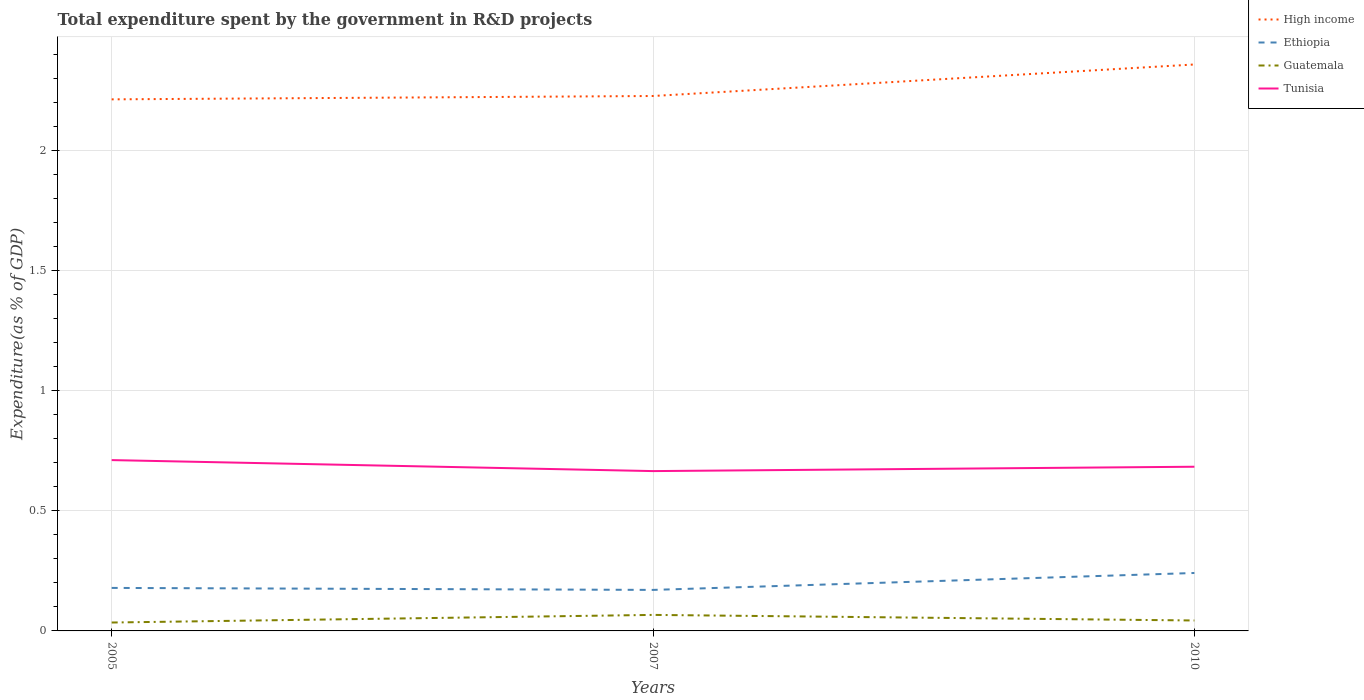How many different coloured lines are there?
Ensure brevity in your answer.  4. Across all years, what is the maximum total expenditure spent by the government in R&D projects in Guatemala?
Keep it short and to the point. 0.04. What is the total total expenditure spent by the government in R&D projects in High income in the graph?
Your response must be concise. -0.01. What is the difference between the highest and the second highest total expenditure spent by the government in R&D projects in Ethiopia?
Make the answer very short. 0.07. What is the difference between two consecutive major ticks on the Y-axis?
Provide a short and direct response. 0.5. Are the values on the major ticks of Y-axis written in scientific E-notation?
Offer a terse response. No. Does the graph contain any zero values?
Offer a very short reply. No. Where does the legend appear in the graph?
Your answer should be very brief. Top right. How are the legend labels stacked?
Keep it short and to the point. Vertical. What is the title of the graph?
Provide a succinct answer. Total expenditure spent by the government in R&D projects. What is the label or title of the Y-axis?
Your answer should be very brief. Expenditure(as % of GDP). What is the Expenditure(as % of GDP) in High income in 2005?
Make the answer very short. 2.21. What is the Expenditure(as % of GDP) of Ethiopia in 2005?
Provide a succinct answer. 0.18. What is the Expenditure(as % of GDP) in Guatemala in 2005?
Give a very brief answer. 0.04. What is the Expenditure(as % of GDP) in Tunisia in 2005?
Your answer should be compact. 0.71. What is the Expenditure(as % of GDP) of High income in 2007?
Make the answer very short. 2.23. What is the Expenditure(as % of GDP) of Ethiopia in 2007?
Give a very brief answer. 0.17. What is the Expenditure(as % of GDP) in Guatemala in 2007?
Offer a very short reply. 0.07. What is the Expenditure(as % of GDP) of Tunisia in 2007?
Provide a succinct answer. 0.67. What is the Expenditure(as % of GDP) in High income in 2010?
Keep it short and to the point. 2.36. What is the Expenditure(as % of GDP) of Ethiopia in 2010?
Offer a very short reply. 0.24. What is the Expenditure(as % of GDP) in Guatemala in 2010?
Provide a short and direct response. 0.04. What is the Expenditure(as % of GDP) of Tunisia in 2010?
Provide a succinct answer. 0.68. Across all years, what is the maximum Expenditure(as % of GDP) in High income?
Make the answer very short. 2.36. Across all years, what is the maximum Expenditure(as % of GDP) in Ethiopia?
Your answer should be compact. 0.24. Across all years, what is the maximum Expenditure(as % of GDP) in Guatemala?
Offer a very short reply. 0.07. Across all years, what is the maximum Expenditure(as % of GDP) in Tunisia?
Offer a terse response. 0.71. Across all years, what is the minimum Expenditure(as % of GDP) in High income?
Give a very brief answer. 2.21. Across all years, what is the minimum Expenditure(as % of GDP) in Ethiopia?
Make the answer very short. 0.17. Across all years, what is the minimum Expenditure(as % of GDP) in Guatemala?
Keep it short and to the point. 0.04. Across all years, what is the minimum Expenditure(as % of GDP) in Tunisia?
Offer a terse response. 0.67. What is the total Expenditure(as % of GDP) in High income in the graph?
Give a very brief answer. 6.8. What is the total Expenditure(as % of GDP) in Ethiopia in the graph?
Provide a short and direct response. 0.59. What is the total Expenditure(as % of GDP) in Guatemala in the graph?
Your answer should be very brief. 0.15. What is the total Expenditure(as % of GDP) of Tunisia in the graph?
Give a very brief answer. 2.06. What is the difference between the Expenditure(as % of GDP) of High income in 2005 and that in 2007?
Provide a succinct answer. -0.01. What is the difference between the Expenditure(as % of GDP) in Ethiopia in 2005 and that in 2007?
Ensure brevity in your answer.  0.01. What is the difference between the Expenditure(as % of GDP) in Guatemala in 2005 and that in 2007?
Ensure brevity in your answer.  -0.03. What is the difference between the Expenditure(as % of GDP) of Tunisia in 2005 and that in 2007?
Make the answer very short. 0.05. What is the difference between the Expenditure(as % of GDP) of High income in 2005 and that in 2010?
Offer a terse response. -0.15. What is the difference between the Expenditure(as % of GDP) of Ethiopia in 2005 and that in 2010?
Your answer should be very brief. -0.06. What is the difference between the Expenditure(as % of GDP) of Guatemala in 2005 and that in 2010?
Provide a short and direct response. -0.01. What is the difference between the Expenditure(as % of GDP) in Tunisia in 2005 and that in 2010?
Provide a short and direct response. 0.03. What is the difference between the Expenditure(as % of GDP) in High income in 2007 and that in 2010?
Offer a very short reply. -0.13. What is the difference between the Expenditure(as % of GDP) in Ethiopia in 2007 and that in 2010?
Keep it short and to the point. -0.07. What is the difference between the Expenditure(as % of GDP) in Guatemala in 2007 and that in 2010?
Give a very brief answer. 0.02. What is the difference between the Expenditure(as % of GDP) in Tunisia in 2007 and that in 2010?
Give a very brief answer. -0.02. What is the difference between the Expenditure(as % of GDP) of High income in 2005 and the Expenditure(as % of GDP) of Ethiopia in 2007?
Your answer should be very brief. 2.04. What is the difference between the Expenditure(as % of GDP) in High income in 2005 and the Expenditure(as % of GDP) in Guatemala in 2007?
Offer a very short reply. 2.15. What is the difference between the Expenditure(as % of GDP) of High income in 2005 and the Expenditure(as % of GDP) of Tunisia in 2007?
Your answer should be very brief. 1.55. What is the difference between the Expenditure(as % of GDP) in Ethiopia in 2005 and the Expenditure(as % of GDP) in Guatemala in 2007?
Make the answer very short. 0.11. What is the difference between the Expenditure(as % of GDP) of Ethiopia in 2005 and the Expenditure(as % of GDP) of Tunisia in 2007?
Keep it short and to the point. -0.49. What is the difference between the Expenditure(as % of GDP) in Guatemala in 2005 and the Expenditure(as % of GDP) in Tunisia in 2007?
Provide a succinct answer. -0.63. What is the difference between the Expenditure(as % of GDP) of High income in 2005 and the Expenditure(as % of GDP) of Ethiopia in 2010?
Offer a terse response. 1.97. What is the difference between the Expenditure(as % of GDP) in High income in 2005 and the Expenditure(as % of GDP) in Guatemala in 2010?
Provide a short and direct response. 2.17. What is the difference between the Expenditure(as % of GDP) of High income in 2005 and the Expenditure(as % of GDP) of Tunisia in 2010?
Your answer should be compact. 1.53. What is the difference between the Expenditure(as % of GDP) of Ethiopia in 2005 and the Expenditure(as % of GDP) of Guatemala in 2010?
Offer a very short reply. 0.14. What is the difference between the Expenditure(as % of GDP) in Ethiopia in 2005 and the Expenditure(as % of GDP) in Tunisia in 2010?
Your response must be concise. -0.5. What is the difference between the Expenditure(as % of GDP) of Guatemala in 2005 and the Expenditure(as % of GDP) of Tunisia in 2010?
Your answer should be very brief. -0.65. What is the difference between the Expenditure(as % of GDP) of High income in 2007 and the Expenditure(as % of GDP) of Ethiopia in 2010?
Keep it short and to the point. 1.99. What is the difference between the Expenditure(as % of GDP) of High income in 2007 and the Expenditure(as % of GDP) of Guatemala in 2010?
Ensure brevity in your answer.  2.19. What is the difference between the Expenditure(as % of GDP) of High income in 2007 and the Expenditure(as % of GDP) of Tunisia in 2010?
Offer a very short reply. 1.54. What is the difference between the Expenditure(as % of GDP) of Ethiopia in 2007 and the Expenditure(as % of GDP) of Guatemala in 2010?
Your response must be concise. 0.13. What is the difference between the Expenditure(as % of GDP) of Ethiopia in 2007 and the Expenditure(as % of GDP) of Tunisia in 2010?
Provide a short and direct response. -0.51. What is the difference between the Expenditure(as % of GDP) of Guatemala in 2007 and the Expenditure(as % of GDP) of Tunisia in 2010?
Make the answer very short. -0.62. What is the average Expenditure(as % of GDP) in High income per year?
Provide a succinct answer. 2.27. What is the average Expenditure(as % of GDP) of Ethiopia per year?
Make the answer very short. 0.2. What is the average Expenditure(as % of GDP) in Guatemala per year?
Your response must be concise. 0.05. What is the average Expenditure(as % of GDP) of Tunisia per year?
Your answer should be compact. 0.69. In the year 2005, what is the difference between the Expenditure(as % of GDP) in High income and Expenditure(as % of GDP) in Ethiopia?
Your answer should be very brief. 2.04. In the year 2005, what is the difference between the Expenditure(as % of GDP) of High income and Expenditure(as % of GDP) of Guatemala?
Your answer should be compact. 2.18. In the year 2005, what is the difference between the Expenditure(as % of GDP) in High income and Expenditure(as % of GDP) in Tunisia?
Give a very brief answer. 1.5. In the year 2005, what is the difference between the Expenditure(as % of GDP) of Ethiopia and Expenditure(as % of GDP) of Guatemala?
Your answer should be very brief. 0.14. In the year 2005, what is the difference between the Expenditure(as % of GDP) in Ethiopia and Expenditure(as % of GDP) in Tunisia?
Your answer should be very brief. -0.53. In the year 2005, what is the difference between the Expenditure(as % of GDP) in Guatemala and Expenditure(as % of GDP) in Tunisia?
Your response must be concise. -0.68. In the year 2007, what is the difference between the Expenditure(as % of GDP) in High income and Expenditure(as % of GDP) in Ethiopia?
Keep it short and to the point. 2.06. In the year 2007, what is the difference between the Expenditure(as % of GDP) in High income and Expenditure(as % of GDP) in Guatemala?
Your answer should be very brief. 2.16. In the year 2007, what is the difference between the Expenditure(as % of GDP) in High income and Expenditure(as % of GDP) in Tunisia?
Offer a terse response. 1.56. In the year 2007, what is the difference between the Expenditure(as % of GDP) of Ethiopia and Expenditure(as % of GDP) of Guatemala?
Provide a succinct answer. 0.1. In the year 2007, what is the difference between the Expenditure(as % of GDP) in Ethiopia and Expenditure(as % of GDP) in Tunisia?
Your response must be concise. -0.49. In the year 2007, what is the difference between the Expenditure(as % of GDP) in Guatemala and Expenditure(as % of GDP) in Tunisia?
Make the answer very short. -0.6. In the year 2010, what is the difference between the Expenditure(as % of GDP) in High income and Expenditure(as % of GDP) in Ethiopia?
Ensure brevity in your answer.  2.12. In the year 2010, what is the difference between the Expenditure(as % of GDP) of High income and Expenditure(as % of GDP) of Guatemala?
Give a very brief answer. 2.32. In the year 2010, what is the difference between the Expenditure(as % of GDP) in High income and Expenditure(as % of GDP) in Tunisia?
Keep it short and to the point. 1.68. In the year 2010, what is the difference between the Expenditure(as % of GDP) of Ethiopia and Expenditure(as % of GDP) of Guatemala?
Offer a terse response. 0.2. In the year 2010, what is the difference between the Expenditure(as % of GDP) in Ethiopia and Expenditure(as % of GDP) in Tunisia?
Keep it short and to the point. -0.44. In the year 2010, what is the difference between the Expenditure(as % of GDP) of Guatemala and Expenditure(as % of GDP) of Tunisia?
Keep it short and to the point. -0.64. What is the ratio of the Expenditure(as % of GDP) of Ethiopia in 2005 to that in 2007?
Your answer should be very brief. 1.05. What is the ratio of the Expenditure(as % of GDP) of Guatemala in 2005 to that in 2007?
Give a very brief answer. 0.52. What is the ratio of the Expenditure(as % of GDP) of Tunisia in 2005 to that in 2007?
Provide a succinct answer. 1.07. What is the ratio of the Expenditure(as % of GDP) of High income in 2005 to that in 2010?
Your response must be concise. 0.94. What is the ratio of the Expenditure(as % of GDP) in Ethiopia in 2005 to that in 2010?
Provide a succinct answer. 0.74. What is the ratio of the Expenditure(as % of GDP) of Guatemala in 2005 to that in 2010?
Make the answer very short. 0.8. What is the ratio of the Expenditure(as % of GDP) of Tunisia in 2005 to that in 2010?
Your response must be concise. 1.04. What is the ratio of the Expenditure(as % of GDP) in Ethiopia in 2007 to that in 2010?
Keep it short and to the point. 0.71. What is the ratio of the Expenditure(as % of GDP) in Guatemala in 2007 to that in 2010?
Provide a short and direct response. 1.53. What is the ratio of the Expenditure(as % of GDP) of Tunisia in 2007 to that in 2010?
Your response must be concise. 0.97. What is the difference between the highest and the second highest Expenditure(as % of GDP) in High income?
Offer a very short reply. 0.13. What is the difference between the highest and the second highest Expenditure(as % of GDP) in Ethiopia?
Keep it short and to the point. 0.06. What is the difference between the highest and the second highest Expenditure(as % of GDP) of Guatemala?
Offer a very short reply. 0.02. What is the difference between the highest and the second highest Expenditure(as % of GDP) in Tunisia?
Your response must be concise. 0.03. What is the difference between the highest and the lowest Expenditure(as % of GDP) in High income?
Make the answer very short. 0.15. What is the difference between the highest and the lowest Expenditure(as % of GDP) of Ethiopia?
Give a very brief answer. 0.07. What is the difference between the highest and the lowest Expenditure(as % of GDP) of Guatemala?
Offer a terse response. 0.03. What is the difference between the highest and the lowest Expenditure(as % of GDP) of Tunisia?
Your answer should be compact. 0.05. 